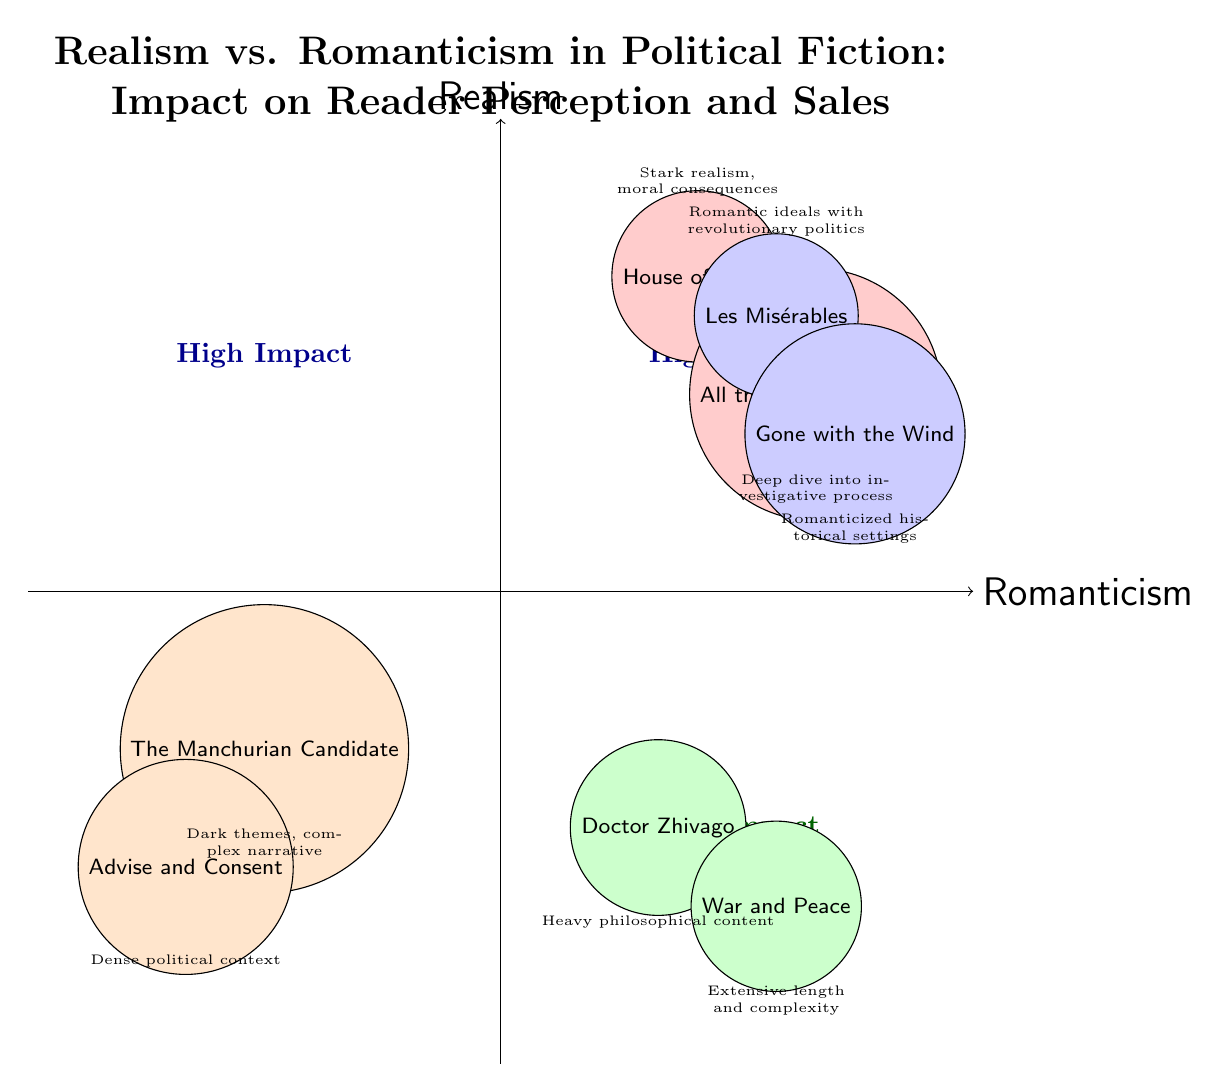What titles are in the High Impact Realism category? According to the diagram, the titles listed in the High Impact Realism category are "House of Cards" and "All the President's Men."
Answer: House of Cards, All the President's Men How many titles are in the Low Impact Romanticism category? The diagram reflects that there are two titles in the Low Impact Romanticism category: "Doctor Zhivago" and "War and Peace."
Answer: 2 Which title has a high impact and combines romantic ideals with revolutionary politics? The title that fits this description in the diagram is "Les Misérables," which is placed in the High Impact Romanticism quadrant.
Answer: Les Misérables What is the primary theme of "House of Cards"? The diagram specifies that "House of Cards" depicts stark realism and moral consequences related to political maneuvering.
Answer: Stark realism, moral consequences Which quadrants contain low impact titles? Two quadrants feature low impact titles: Low Impact Realism and Low Impact Romanticism, identified in the bottom sections of the quadrant chart.
Answer: Low Impact Realism, Low Impact Romanticism How does "Gone with the Wind" impact reader perception? The diagram states that "Gone with the Wind" combines romanticized narratives with historical political settings, leading to significant impact on reader perception.
Answer: Significant impact Which title is characterized by a heavy philosophical content? The title noted for having heavy philosophical content in the Low Impact Romanticism quadrant is "Doctor Zhivago."
Answer: Doctor Zhivago What are the two titles associated with High Impact in Romanticism? The High Impact Romanticism quadrant lists "Les Misérables" and "Gone with the Wind" as the two associated titles.
Answer: Les Misérables, Gone with the Wind Which title has dense political context yet low impact? The title identified with dense political context but low impact is "Advise and Consent", as shown in the Low Impact Realism quadrant.
Answer: Advise and Consent 